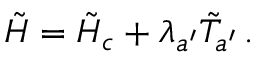<formula> <loc_0><loc_0><loc_500><loc_500>\tilde { H } = \tilde { H } _ { c } + \lambda _ { a ^ { \prime } } \tilde { T } _ { a ^ { \prime } } \, .</formula> 